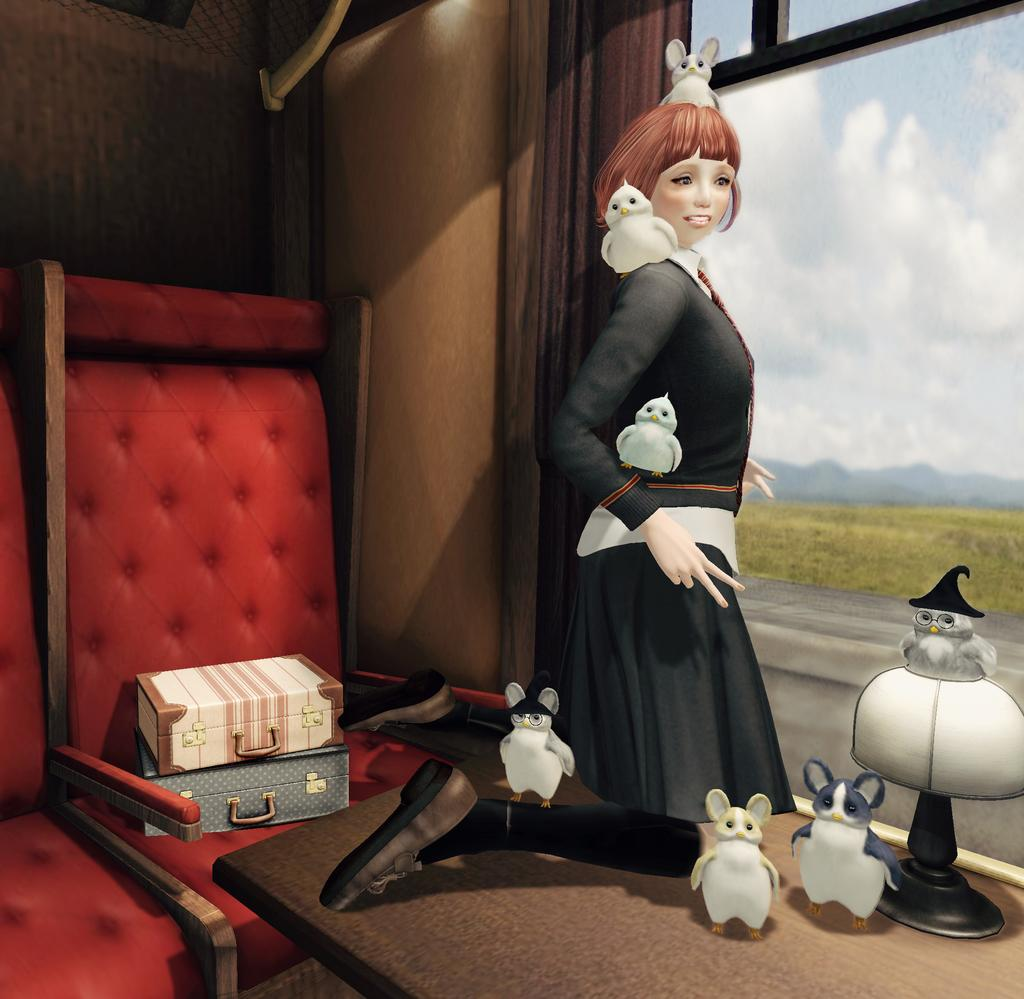Who is the main subject in the image? There is a girl in the image. What else can be seen around the girl? There are animals around the girl. What furniture is visible in the image? There are two chairs behind the girl. Are there any objects on the chairs? Yes, there are two boxes on one of the chairs. What type of arch can be seen in the background of the image? There is no arch present in the image. What company does the girl work for in the image? The image does not provide any information about the girl's job or company. 